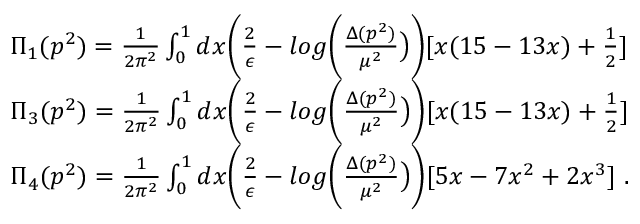Convert formula to latex. <formula><loc_0><loc_0><loc_500><loc_500>\begin{array} { r l } & { \Pi _ { 1 } ( p ^ { 2 } ) = \frac { 1 } { 2 \pi ^ { 2 } } \int _ { 0 } ^ { 1 } d x \left ( \frac { 2 } { \epsilon } - \log \left ( \frac { \Delta ( p ^ { 2 } ) } { \mu ^ { 2 } } \right ) \right ) [ x ( 1 5 - 1 3 x ) + \frac { 1 } { 2 } ] } \\ & { \Pi _ { 3 } ( p ^ { 2 } ) = \frac { 1 } { 2 \pi ^ { 2 } } \int _ { 0 } ^ { 1 } d x \left ( \frac { 2 } { \epsilon } - \log \left ( \frac { \Delta ( p ^ { 2 } ) } { \mu ^ { 2 } } \right ) \right ) [ x ( 1 5 - 1 3 x ) + \frac { 1 } { 2 } ] } \\ & { \Pi _ { 4 } ( p ^ { 2 } ) = \frac { 1 } { 2 \pi ^ { 2 } } \int _ { 0 } ^ { 1 } d x \left ( \frac { 2 } { \epsilon } - \log \left ( \frac { \Delta ( p ^ { 2 } ) } { \mu ^ { 2 } } \right ) \right ) [ 5 x - 7 x ^ { 2 } + 2 x ^ { 3 } ] \ . } \end{array}</formula> 